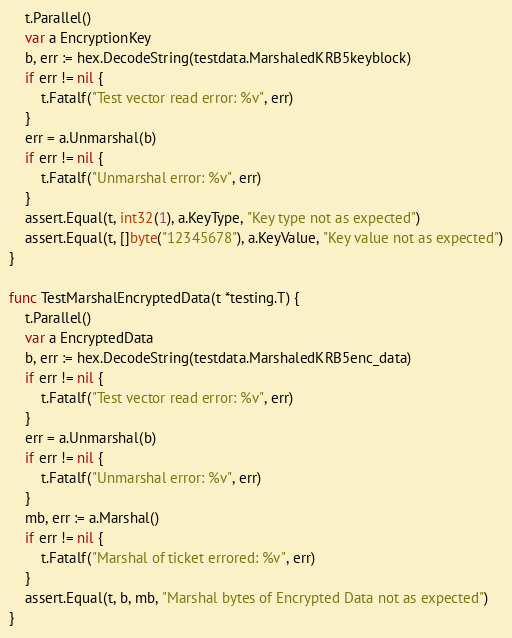Convert code to text. <code><loc_0><loc_0><loc_500><loc_500><_Go_>	t.Parallel()
	var a EncryptionKey
	b, err := hex.DecodeString(testdata.MarshaledKRB5keyblock)
	if err != nil {
		t.Fatalf("Test vector read error: %v", err)
	}
	err = a.Unmarshal(b)
	if err != nil {
		t.Fatalf("Unmarshal error: %v", err)
	}
	assert.Equal(t, int32(1), a.KeyType, "Key type not as expected")
	assert.Equal(t, []byte("12345678"), a.KeyValue, "Key value not as expected")
}

func TestMarshalEncryptedData(t *testing.T) {
	t.Parallel()
	var a EncryptedData
	b, err := hex.DecodeString(testdata.MarshaledKRB5enc_data)
	if err != nil {
		t.Fatalf("Test vector read error: %v", err)
	}
	err = a.Unmarshal(b)
	if err != nil {
		t.Fatalf("Unmarshal error: %v", err)
	}
	mb, err := a.Marshal()
	if err != nil {
		t.Fatalf("Marshal of ticket errored: %v", err)
	}
	assert.Equal(t, b, mb, "Marshal bytes of Encrypted Data not as expected")
}
</code> 